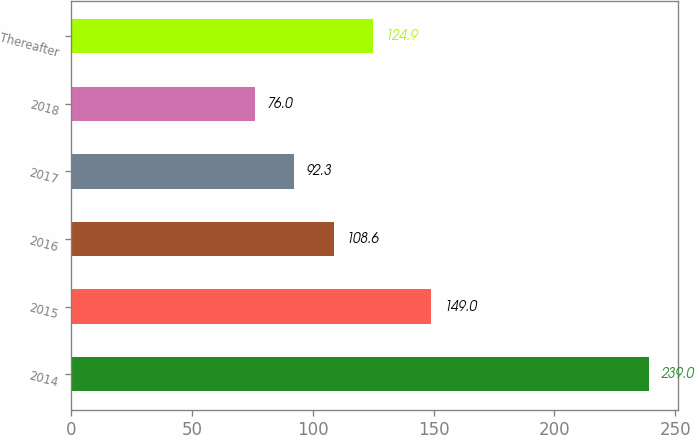Convert chart to OTSL. <chart><loc_0><loc_0><loc_500><loc_500><bar_chart><fcel>2014<fcel>2015<fcel>2016<fcel>2017<fcel>2018<fcel>Thereafter<nl><fcel>239<fcel>149<fcel>108.6<fcel>92.3<fcel>76<fcel>124.9<nl></chart> 